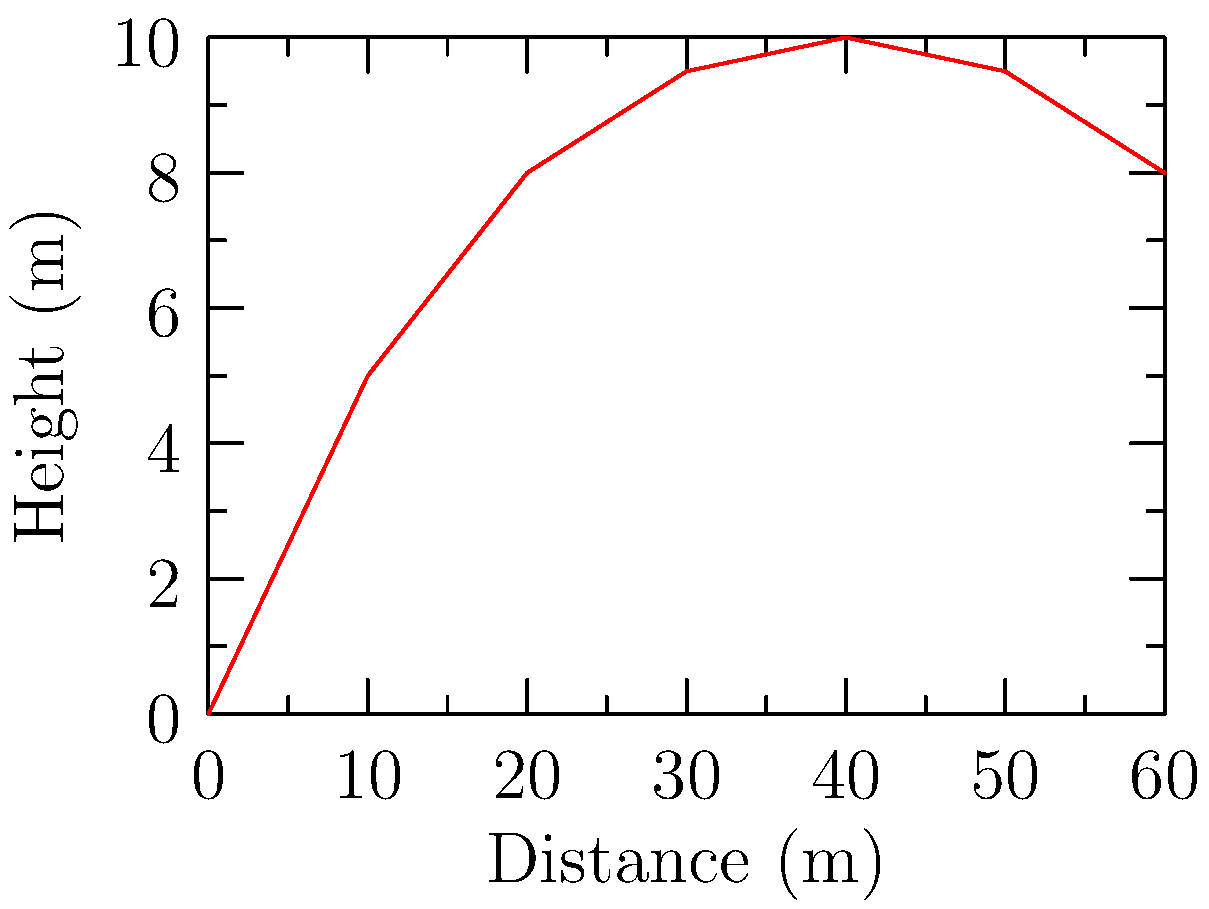On a shinty field, you need to hit a target at a specific distance and height. The graph shows the trajectory of the ball for a given angle of elevation. If the target is located 40 meters away from the starting point, what is the approximate angle of elevation needed to hit the target? To find the angle of elevation, we need to follow these steps:

1. Identify the target location on the graph:
   - Distance: 40 meters
   - Height: 10 meters (from the graph)

2. Calculate the tangent of the angle of elevation:
   $\tan(\theta) = \frac{\text{opposite}}{\text{adjacent}} = \frac{\text{height}}{\text{distance}}$

3. Substitute the values:
   $\tan(\theta) = \frac{10\text{ m}}{40\text{ m}} = 0.25$

4. Calculate the angle using the inverse tangent (arctangent) function:
   $\theta = \arctan(0.25)$

5. Convert the result to degrees:
   $\theta \approx 14.04^\circ$

Therefore, the approximate angle of elevation needed to hit the target is about 14 degrees.
Answer: $14^\circ$ 